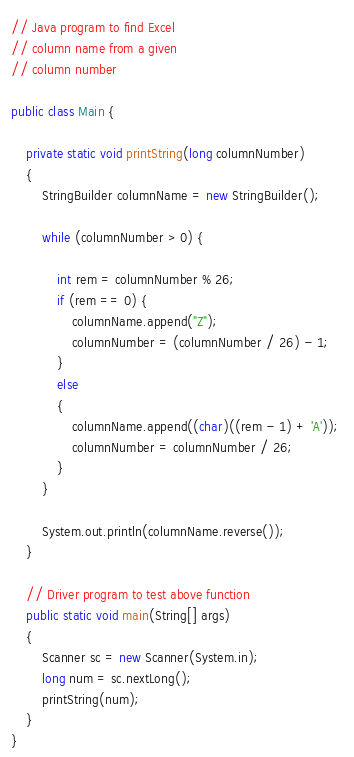Convert code to text. <code><loc_0><loc_0><loc_500><loc_500><_Java_>// Java program to find Excel 
// column name from a given 
// column number 

public class Main { 
	
	private static void printString(long columnNumber) 
	{ 
		StringBuilder columnName = new StringBuilder(); 

		while (columnNumber > 0) { 
		
			int rem = columnNumber % 26; 
			if (rem == 0) { 
				columnName.append("Z"); 
				columnNumber = (columnNumber / 26) - 1; 
			} 
			else 
			{ 
				columnName.append((char)((rem - 1) + 'A')); 
				columnNumber = columnNumber / 26; 
			} 
		} 

		System.out.println(columnName.reverse()); 
	} 

	// Driver program to test above function 
	public static void main(String[] args) 
	{ 
		Scanner sc = new Scanner(System.in);
      	long num = sc.nextLong();
      	printString(num);
	} 
} 

</code> 